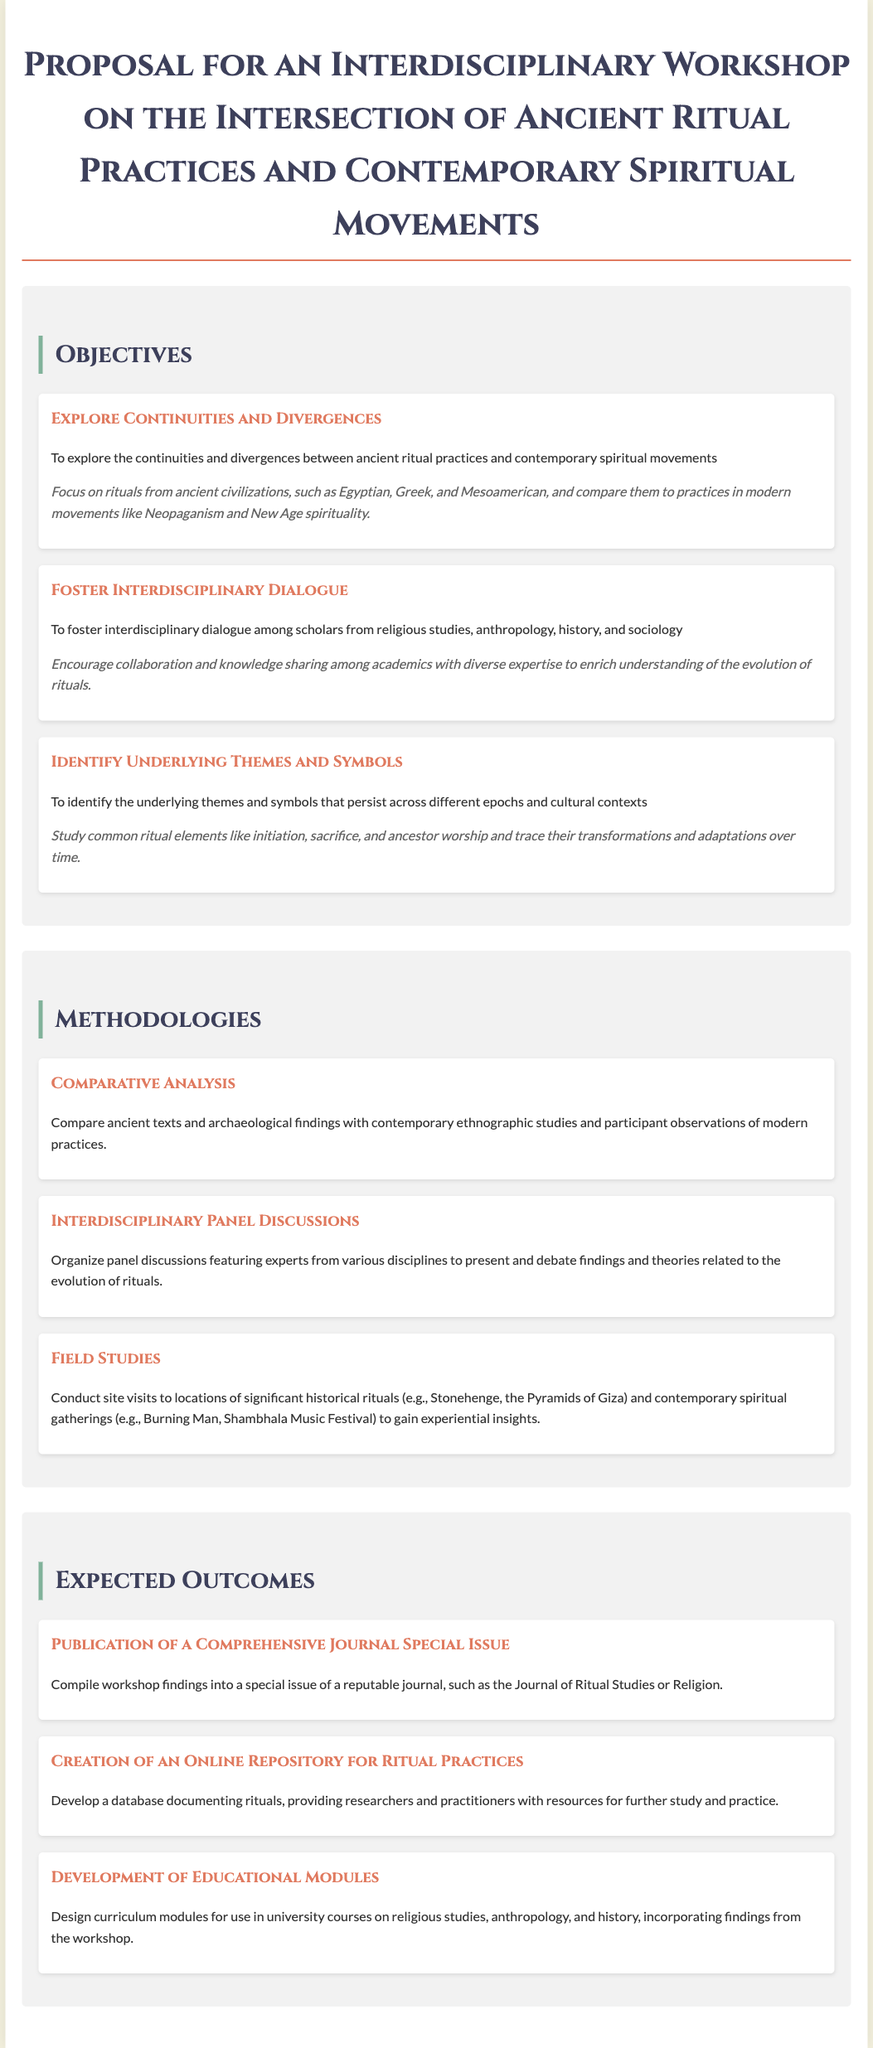What is the title of the workshop proposal? The title is presented in the document header, summarizing the theme of the workshop.
Answer: Proposal for an Interdisciplinary Workshop on the Intersection of Ancient Ritual Practices and Contemporary Spiritual Movements How many objectives are listed in the proposal? The document outlines a total of three specific objectives under the Objectives section.
Answer: 3 What is one methodology mentioned for the workshop? The document lists various methodologies used in the workshop, including an example that is clearly highlighted.
Answer: Comparative Analysis What is a significant outcome expected from the workshop? The expected outcomes are compiled into a distinct section, one of which outlines a notable achievement from the workshop.
Answer: Publication of a Comprehensive Journal Special Issue Which ancient civilizations is the workshop focusing on? The document explicitly states the civilizations being studied under its objectives, giving a clear context.
Answer: Egyptian, Greek, and Mesoamerican Who is the target participants for the interdisciplinary dialogue? The participants of the proposed dialogue are identified by their academic backgrounds and areas of expertise.
Answer: Scholars from religious studies, anthropology, history, and sociology What type of studies will be compared in the methodologies? The methodologies describe the comparisons being made between two different kinds of studies relevant to the workshop's theme.
Answer: Ancient texts and contemporary ethnographic studies What will be developed as part of the workshop outcomes? One of the tangible outcomes mentioned is aimed at creating resources for researchers and practitioners in the field.
Answer: Creation of an Online Repository for Ritual Practices 